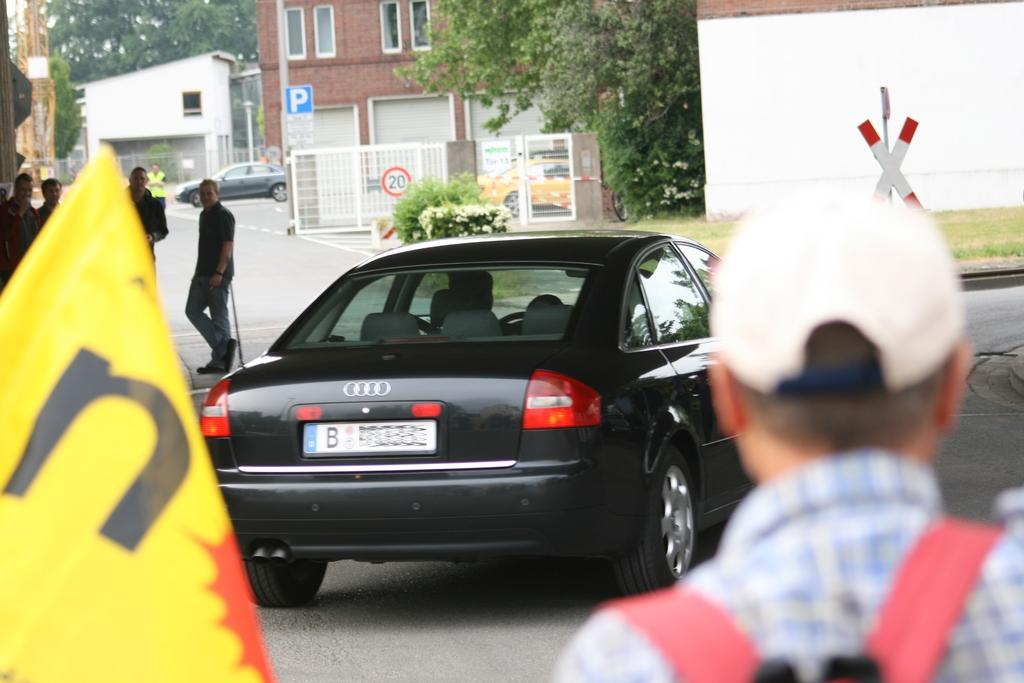<image>
Give a short and clear explanation of the subsequent image. People watching a black car with a license plate that has a letter B. 